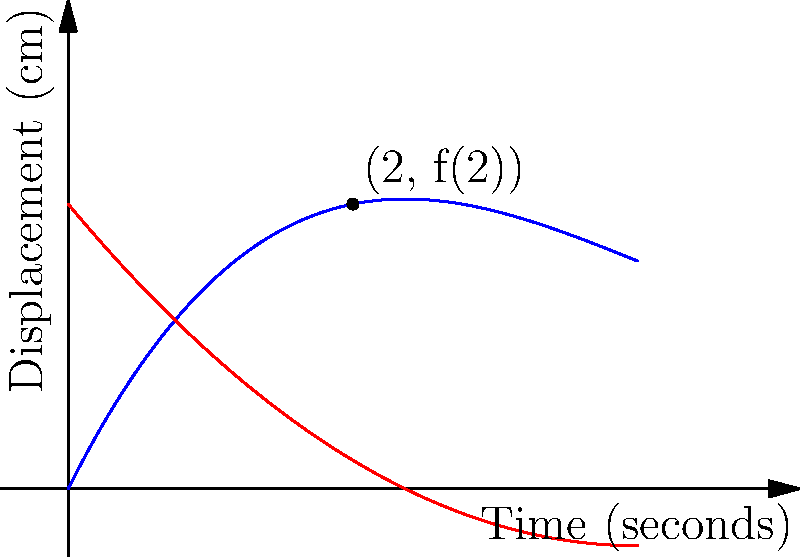In a recording of Beethoven's "Moonlight Sonata," the motion of a piano key is modeled by the function $f(t) = 0.05t^3 - 0.6t^2 + 2t$, where $t$ is time in seconds and $f(t)$ is displacement in centimeters. Calculate the instantaneous rate of change of the key's displacement at $t = 2$ seconds. To find the instantaneous rate of change at $t = 2$, we need to calculate the derivative of $f(t)$ and evaluate it at $t = 2$.

1) First, let's find $f'(t)$ using the power rule:
   $f'(t) = 0.15t^2 - 1.2t + 2$

2) Now, we evaluate $f'(2)$:
   $f'(2) = 0.15(2)^2 - 1.2(2) + 2$
   $f'(2) = 0.15(4) - 2.4 + 2$
   $f'(2) = 0.6 - 2.4 + 2$
   $f'(2) = 0.2$

3) The instantaneous rate of change at $t = 2$ is the value of $f'(2)$, which is 0.2 cm/s.

The red line in the graph represents the tangent line at $t = 2$, whose slope is equal to this instantaneous rate of change.
Answer: 0.2 cm/s 